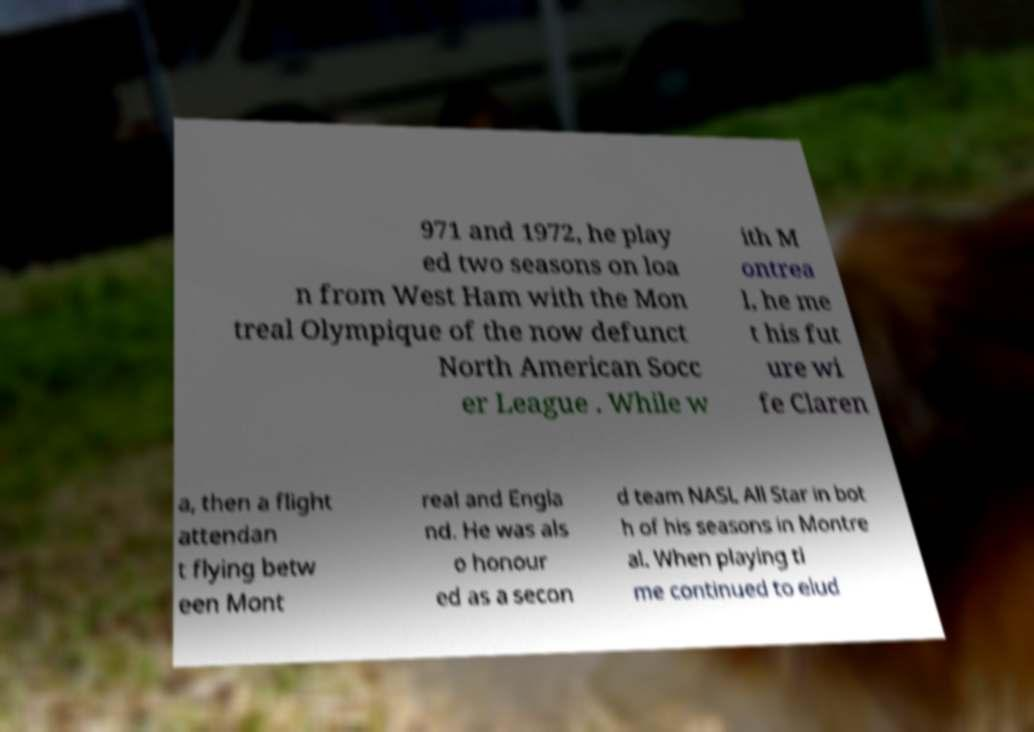There's text embedded in this image that I need extracted. Can you transcribe it verbatim? 971 and 1972, he play ed two seasons on loa n from West Ham with the Mon treal Olympique of the now defunct North American Socc er League . While w ith M ontrea l, he me t his fut ure wi fe Claren a, then a flight attendan t flying betw een Mont real and Engla nd. He was als o honour ed as a secon d team NASL All Star in bot h of his seasons in Montre al. When playing ti me continued to elud 